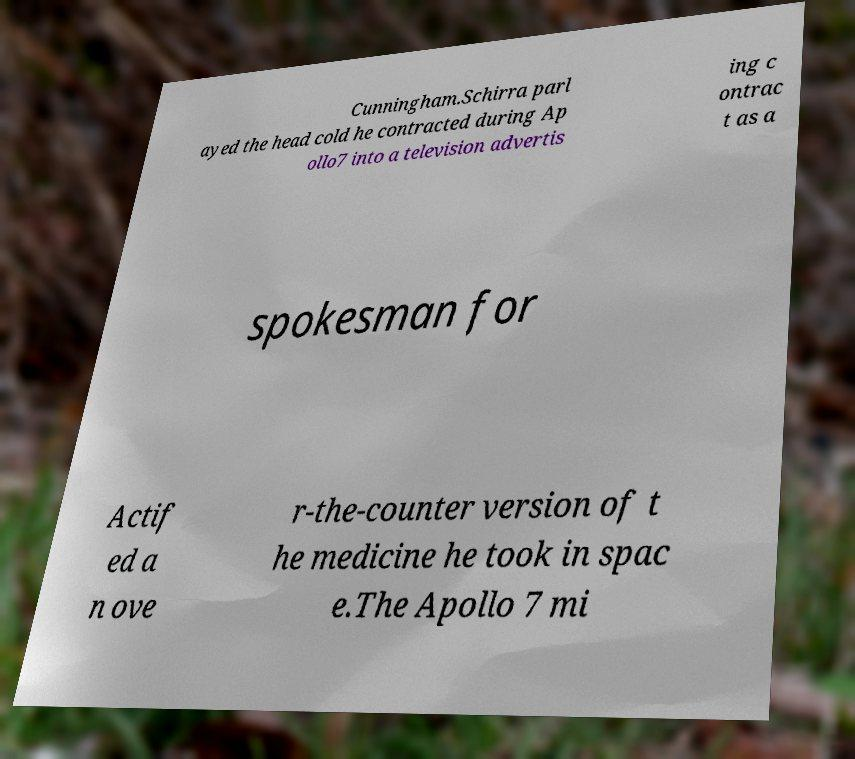Please identify and transcribe the text found in this image. Cunningham.Schirra parl ayed the head cold he contracted during Ap ollo7 into a television advertis ing c ontrac t as a spokesman for Actif ed a n ove r-the-counter version of t he medicine he took in spac e.The Apollo 7 mi 